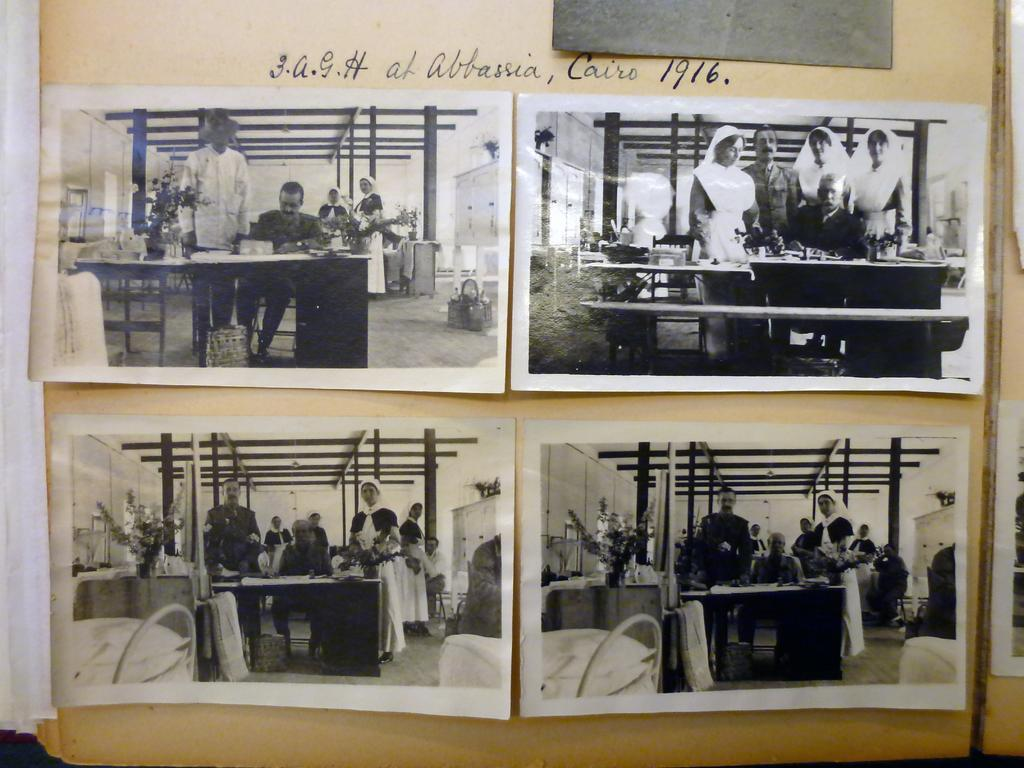What type of images are present in the image? There are photographs in the image. What can be seen in the photographs? The photographs contain persons and other objects. Is there any written information in the image? Yes, there is text in the image. What type of soda is being consumed by the person in the image? There is no soda present in the image; it only contains photographs with persons and objects. Can you hear the rhythm of the crow in the image? There is no crow or rhythm present in the image; it only contains photographs with text. 